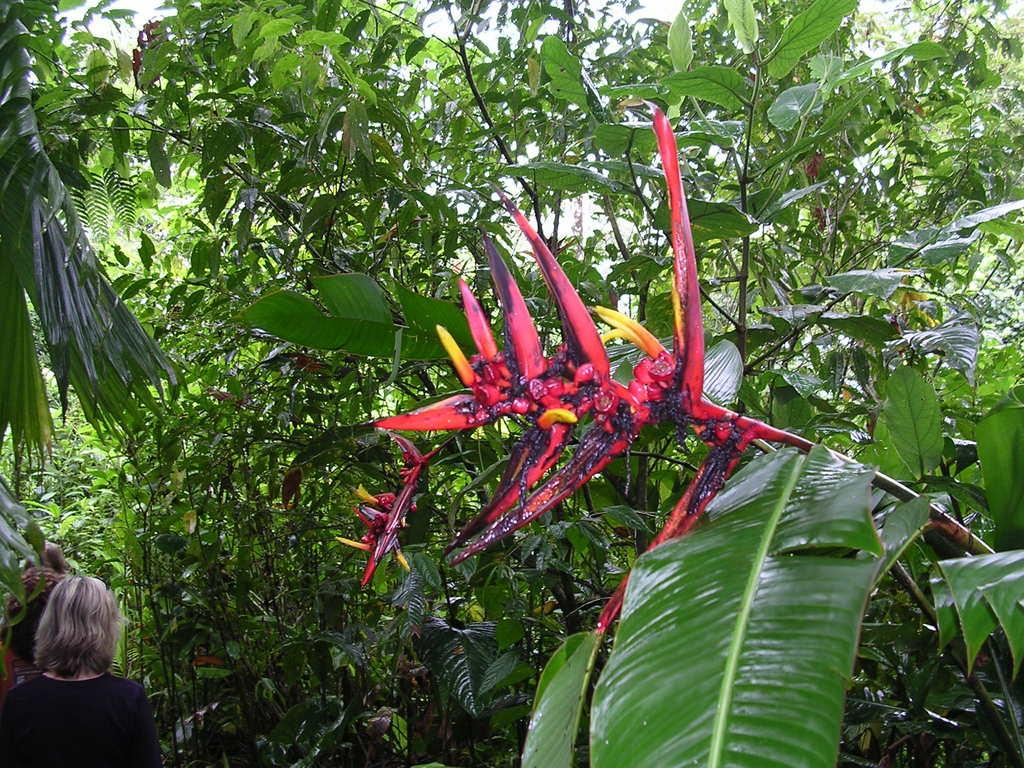What type of vegetation can be seen in the image? There are trees and plants in the image. Can you describe the people on the left side of the image? There are persons on the left side of the image. What is the mother teaching her child in the image? There is no mother or child present in the image, and therefore no teaching activity can be observed. What feeling is expressed by the persons on the left side of the image? The provided facts do not mention any emotions or feelings expressed by the persons in the image. 